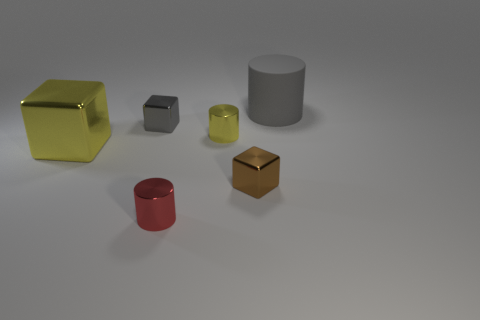How might the lighting in this image affect the perception of the objects? The lighting in this image appears to be coming from above, casting soft shadows directly under the objects. It enhances the perception of the three-dimensional forms and provides a sense of depth. The softness of the shadows suggests a diffuse light source, which results in gentle contrasts and allows the materials' textures to be more apparent. 